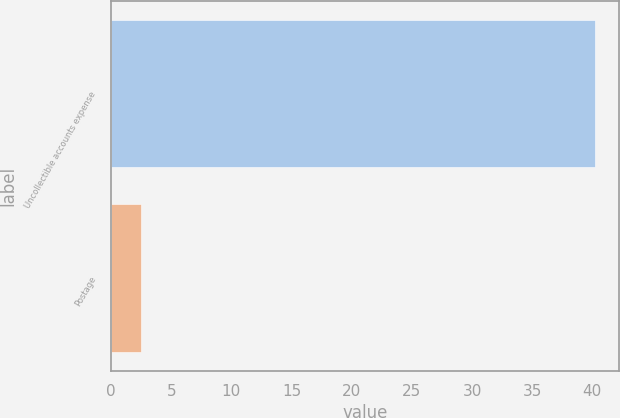Convert chart to OTSL. <chart><loc_0><loc_0><loc_500><loc_500><bar_chart><fcel>Uncollectible accounts expense<fcel>Postage<nl><fcel>40.2<fcel>2.5<nl></chart> 